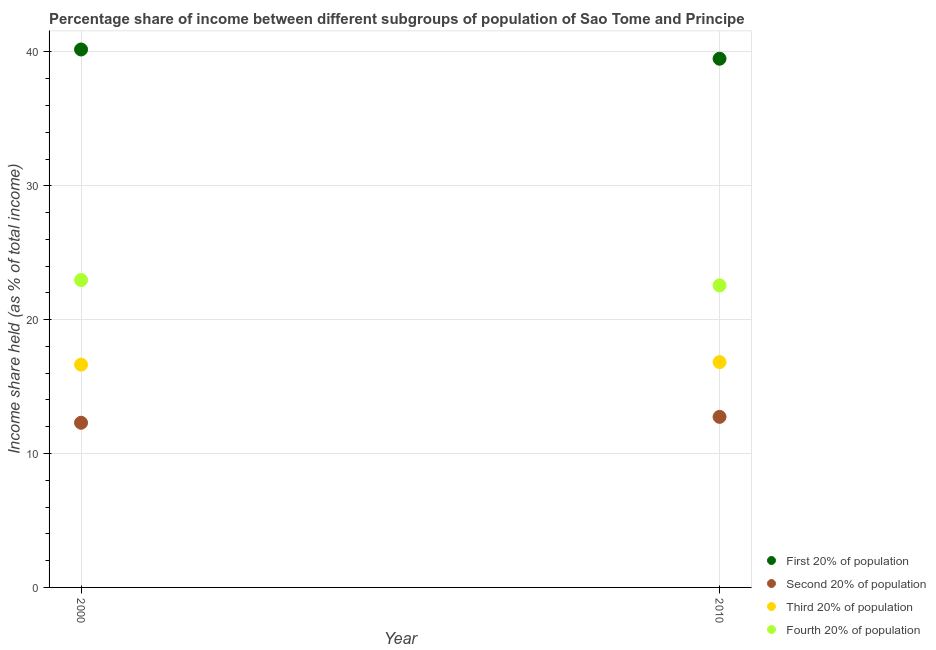How many different coloured dotlines are there?
Your answer should be compact. 4. Is the number of dotlines equal to the number of legend labels?
Ensure brevity in your answer.  Yes. What is the share of the income held by second 20% of the population in 2010?
Your answer should be very brief. 12.74. Across all years, what is the maximum share of the income held by second 20% of the population?
Ensure brevity in your answer.  12.74. Across all years, what is the minimum share of the income held by first 20% of the population?
Your answer should be very brief. 39.49. What is the total share of the income held by second 20% of the population in the graph?
Make the answer very short. 25.04. What is the difference between the share of the income held by third 20% of the population in 2000 and that in 2010?
Your answer should be compact. -0.19. What is the difference between the share of the income held by second 20% of the population in 2010 and the share of the income held by fourth 20% of the population in 2000?
Your response must be concise. -10.22. What is the average share of the income held by third 20% of the population per year?
Your answer should be very brief. 16.73. In the year 2010, what is the difference between the share of the income held by fourth 20% of the population and share of the income held by third 20% of the population?
Provide a short and direct response. 5.73. What is the ratio of the share of the income held by second 20% of the population in 2000 to that in 2010?
Keep it short and to the point. 0.97. Is the share of the income held by first 20% of the population in 2000 less than that in 2010?
Provide a succinct answer. No. In how many years, is the share of the income held by second 20% of the population greater than the average share of the income held by second 20% of the population taken over all years?
Keep it short and to the point. 1. Is it the case that in every year, the sum of the share of the income held by fourth 20% of the population and share of the income held by second 20% of the population is greater than the sum of share of the income held by first 20% of the population and share of the income held by third 20% of the population?
Ensure brevity in your answer.  No. Does the share of the income held by second 20% of the population monotonically increase over the years?
Make the answer very short. Yes. Is the share of the income held by fourth 20% of the population strictly less than the share of the income held by third 20% of the population over the years?
Offer a very short reply. No. How many years are there in the graph?
Provide a succinct answer. 2. Are the values on the major ticks of Y-axis written in scientific E-notation?
Ensure brevity in your answer.  No. Does the graph contain any zero values?
Ensure brevity in your answer.  No. How many legend labels are there?
Your answer should be compact. 4. What is the title of the graph?
Your answer should be very brief. Percentage share of income between different subgroups of population of Sao Tome and Principe. Does "Others" appear as one of the legend labels in the graph?
Your response must be concise. No. What is the label or title of the Y-axis?
Your answer should be compact. Income share held (as % of total income). What is the Income share held (as % of total income) in First 20% of population in 2000?
Give a very brief answer. 40.18. What is the Income share held (as % of total income) of Second 20% of population in 2000?
Offer a very short reply. 12.3. What is the Income share held (as % of total income) in Third 20% of population in 2000?
Offer a very short reply. 16.64. What is the Income share held (as % of total income) in Fourth 20% of population in 2000?
Keep it short and to the point. 22.96. What is the Income share held (as % of total income) of First 20% of population in 2010?
Offer a very short reply. 39.49. What is the Income share held (as % of total income) of Second 20% of population in 2010?
Your answer should be compact. 12.74. What is the Income share held (as % of total income) of Third 20% of population in 2010?
Your answer should be very brief. 16.83. What is the Income share held (as % of total income) of Fourth 20% of population in 2010?
Provide a succinct answer. 22.56. Across all years, what is the maximum Income share held (as % of total income) of First 20% of population?
Your answer should be very brief. 40.18. Across all years, what is the maximum Income share held (as % of total income) of Second 20% of population?
Keep it short and to the point. 12.74. Across all years, what is the maximum Income share held (as % of total income) in Third 20% of population?
Your answer should be compact. 16.83. Across all years, what is the maximum Income share held (as % of total income) of Fourth 20% of population?
Your answer should be very brief. 22.96. Across all years, what is the minimum Income share held (as % of total income) in First 20% of population?
Your response must be concise. 39.49. Across all years, what is the minimum Income share held (as % of total income) of Second 20% of population?
Ensure brevity in your answer.  12.3. Across all years, what is the minimum Income share held (as % of total income) of Third 20% of population?
Provide a short and direct response. 16.64. Across all years, what is the minimum Income share held (as % of total income) of Fourth 20% of population?
Make the answer very short. 22.56. What is the total Income share held (as % of total income) in First 20% of population in the graph?
Offer a very short reply. 79.67. What is the total Income share held (as % of total income) of Second 20% of population in the graph?
Give a very brief answer. 25.04. What is the total Income share held (as % of total income) of Third 20% of population in the graph?
Provide a short and direct response. 33.47. What is the total Income share held (as % of total income) in Fourth 20% of population in the graph?
Ensure brevity in your answer.  45.52. What is the difference between the Income share held (as % of total income) of First 20% of population in 2000 and that in 2010?
Offer a terse response. 0.69. What is the difference between the Income share held (as % of total income) in Second 20% of population in 2000 and that in 2010?
Make the answer very short. -0.44. What is the difference between the Income share held (as % of total income) of Third 20% of population in 2000 and that in 2010?
Keep it short and to the point. -0.19. What is the difference between the Income share held (as % of total income) of First 20% of population in 2000 and the Income share held (as % of total income) of Second 20% of population in 2010?
Keep it short and to the point. 27.44. What is the difference between the Income share held (as % of total income) of First 20% of population in 2000 and the Income share held (as % of total income) of Third 20% of population in 2010?
Make the answer very short. 23.35. What is the difference between the Income share held (as % of total income) in First 20% of population in 2000 and the Income share held (as % of total income) in Fourth 20% of population in 2010?
Your response must be concise. 17.62. What is the difference between the Income share held (as % of total income) of Second 20% of population in 2000 and the Income share held (as % of total income) of Third 20% of population in 2010?
Your answer should be compact. -4.53. What is the difference between the Income share held (as % of total income) of Second 20% of population in 2000 and the Income share held (as % of total income) of Fourth 20% of population in 2010?
Provide a succinct answer. -10.26. What is the difference between the Income share held (as % of total income) of Third 20% of population in 2000 and the Income share held (as % of total income) of Fourth 20% of population in 2010?
Your answer should be very brief. -5.92. What is the average Income share held (as % of total income) in First 20% of population per year?
Your answer should be compact. 39.84. What is the average Income share held (as % of total income) in Second 20% of population per year?
Ensure brevity in your answer.  12.52. What is the average Income share held (as % of total income) in Third 20% of population per year?
Make the answer very short. 16.73. What is the average Income share held (as % of total income) in Fourth 20% of population per year?
Your response must be concise. 22.76. In the year 2000, what is the difference between the Income share held (as % of total income) in First 20% of population and Income share held (as % of total income) in Second 20% of population?
Provide a succinct answer. 27.88. In the year 2000, what is the difference between the Income share held (as % of total income) in First 20% of population and Income share held (as % of total income) in Third 20% of population?
Make the answer very short. 23.54. In the year 2000, what is the difference between the Income share held (as % of total income) in First 20% of population and Income share held (as % of total income) in Fourth 20% of population?
Ensure brevity in your answer.  17.22. In the year 2000, what is the difference between the Income share held (as % of total income) in Second 20% of population and Income share held (as % of total income) in Third 20% of population?
Ensure brevity in your answer.  -4.34. In the year 2000, what is the difference between the Income share held (as % of total income) in Second 20% of population and Income share held (as % of total income) in Fourth 20% of population?
Ensure brevity in your answer.  -10.66. In the year 2000, what is the difference between the Income share held (as % of total income) of Third 20% of population and Income share held (as % of total income) of Fourth 20% of population?
Provide a succinct answer. -6.32. In the year 2010, what is the difference between the Income share held (as % of total income) in First 20% of population and Income share held (as % of total income) in Second 20% of population?
Provide a short and direct response. 26.75. In the year 2010, what is the difference between the Income share held (as % of total income) in First 20% of population and Income share held (as % of total income) in Third 20% of population?
Provide a succinct answer. 22.66. In the year 2010, what is the difference between the Income share held (as % of total income) of First 20% of population and Income share held (as % of total income) of Fourth 20% of population?
Ensure brevity in your answer.  16.93. In the year 2010, what is the difference between the Income share held (as % of total income) of Second 20% of population and Income share held (as % of total income) of Third 20% of population?
Offer a terse response. -4.09. In the year 2010, what is the difference between the Income share held (as % of total income) of Second 20% of population and Income share held (as % of total income) of Fourth 20% of population?
Make the answer very short. -9.82. In the year 2010, what is the difference between the Income share held (as % of total income) in Third 20% of population and Income share held (as % of total income) in Fourth 20% of population?
Give a very brief answer. -5.73. What is the ratio of the Income share held (as % of total income) of First 20% of population in 2000 to that in 2010?
Your answer should be very brief. 1.02. What is the ratio of the Income share held (as % of total income) of Second 20% of population in 2000 to that in 2010?
Your answer should be very brief. 0.97. What is the ratio of the Income share held (as % of total income) of Third 20% of population in 2000 to that in 2010?
Your response must be concise. 0.99. What is the ratio of the Income share held (as % of total income) of Fourth 20% of population in 2000 to that in 2010?
Your answer should be compact. 1.02. What is the difference between the highest and the second highest Income share held (as % of total income) in First 20% of population?
Provide a succinct answer. 0.69. What is the difference between the highest and the second highest Income share held (as % of total income) of Second 20% of population?
Give a very brief answer. 0.44. What is the difference between the highest and the second highest Income share held (as % of total income) of Third 20% of population?
Provide a succinct answer. 0.19. What is the difference between the highest and the second highest Income share held (as % of total income) of Fourth 20% of population?
Offer a terse response. 0.4. What is the difference between the highest and the lowest Income share held (as % of total income) of First 20% of population?
Keep it short and to the point. 0.69. What is the difference between the highest and the lowest Income share held (as % of total income) of Second 20% of population?
Your answer should be compact. 0.44. What is the difference between the highest and the lowest Income share held (as % of total income) in Third 20% of population?
Your response must be concise. 0.19. 